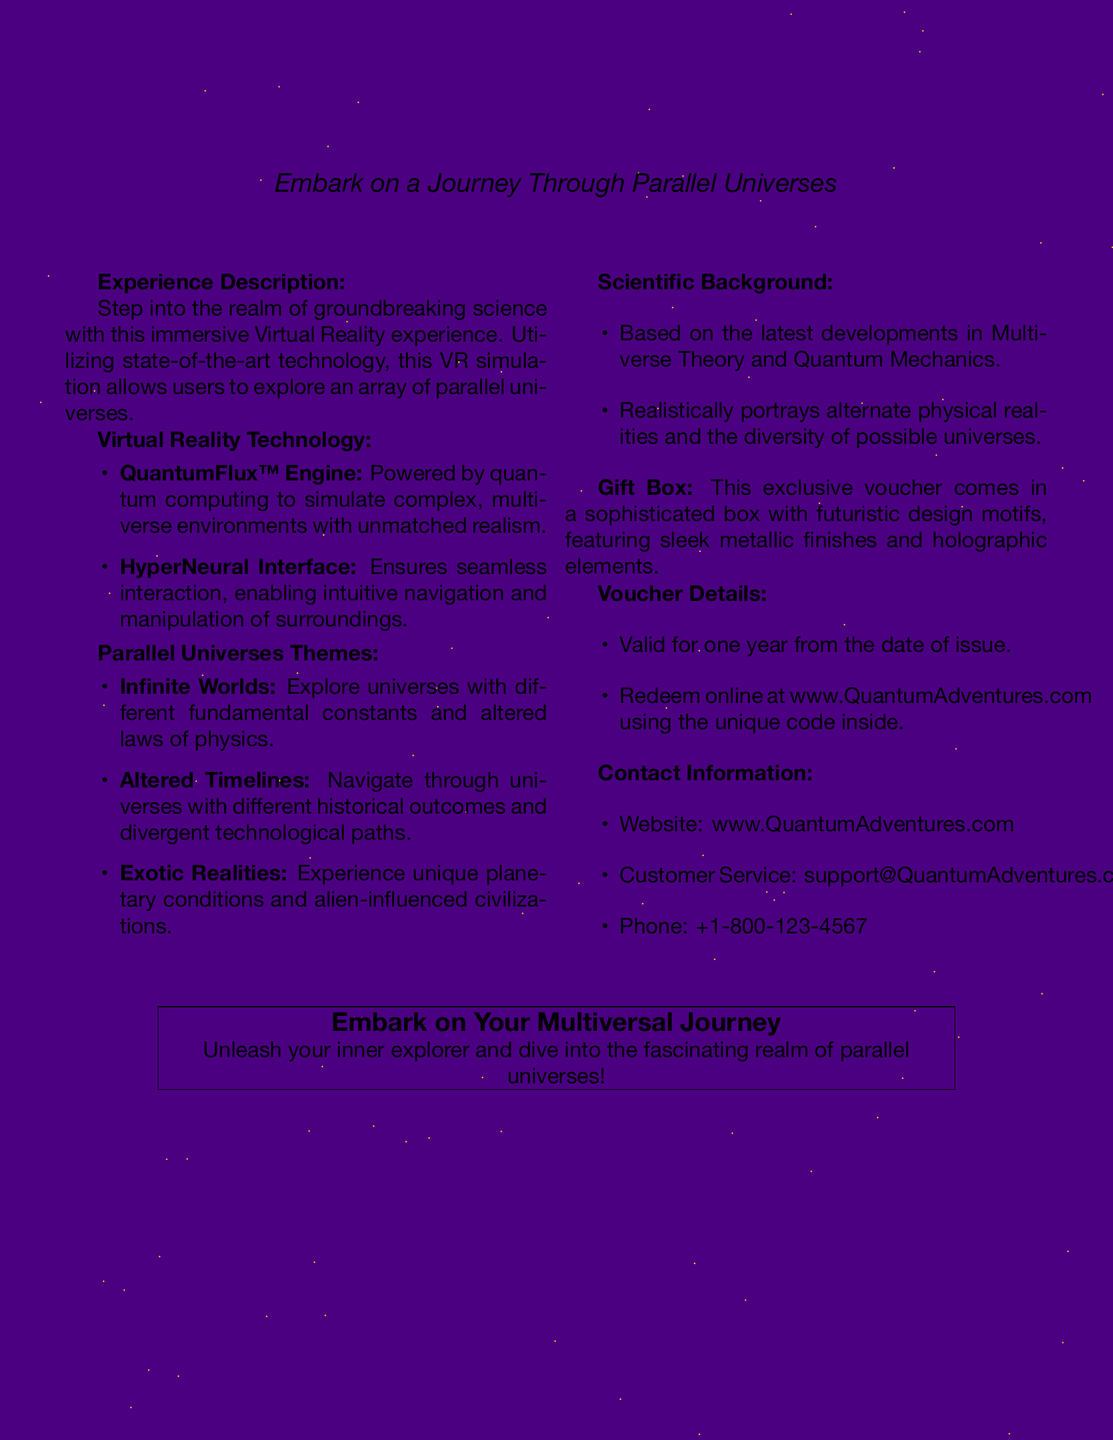What is the name of the VR engine used? The name of the VR engine utilized is mentioned in the document as QuantumFlux™ Engine.
Answer: QuantumFlux™ Engine What does the gift voucher allow you to explore? The gift voucher allows you to explore an array of parallel universes as detailed in the experience description.
Answer: Parallel universes How long is the voucher valid for? The document specifies that the voucher is valid for one year from the date of issue.
Answer: One year What type of interface does the VR experience use? The document describes the interface as the HyperNeural Interface, which is designed for intuitive interaction.
Answer: HyperNeural Interface Which theme involves navigating through different historical outcomes? The document reveals that the theme in question is Altered Timelines, where users can navigate alternate historical outcomes.
Answer: Altered Timelines What is the contact email for customer service? The contact email for customer service is provided in the document for inquiries regarding the voucher.
Answer: support@QuantumAdventures.com What is featured on the sophisticated gift box? The document notes that the box contains futuristic design motifs, including sleek metallic finishes and holographic elements.
Answer: Futuristic design motifs How can the voucher be redeemed? According to the document, users can redeem the voucher online at the specified website using a unique code.
Answer: Online at www.QuantumAdventures.com What concept is the experience based on? The immersive experience draws on the latest developments in Multiverse Theory and Quantum Mechanics as stated in the scientific background.
Answer: Multiverse Theory and Quantum Mechanics 